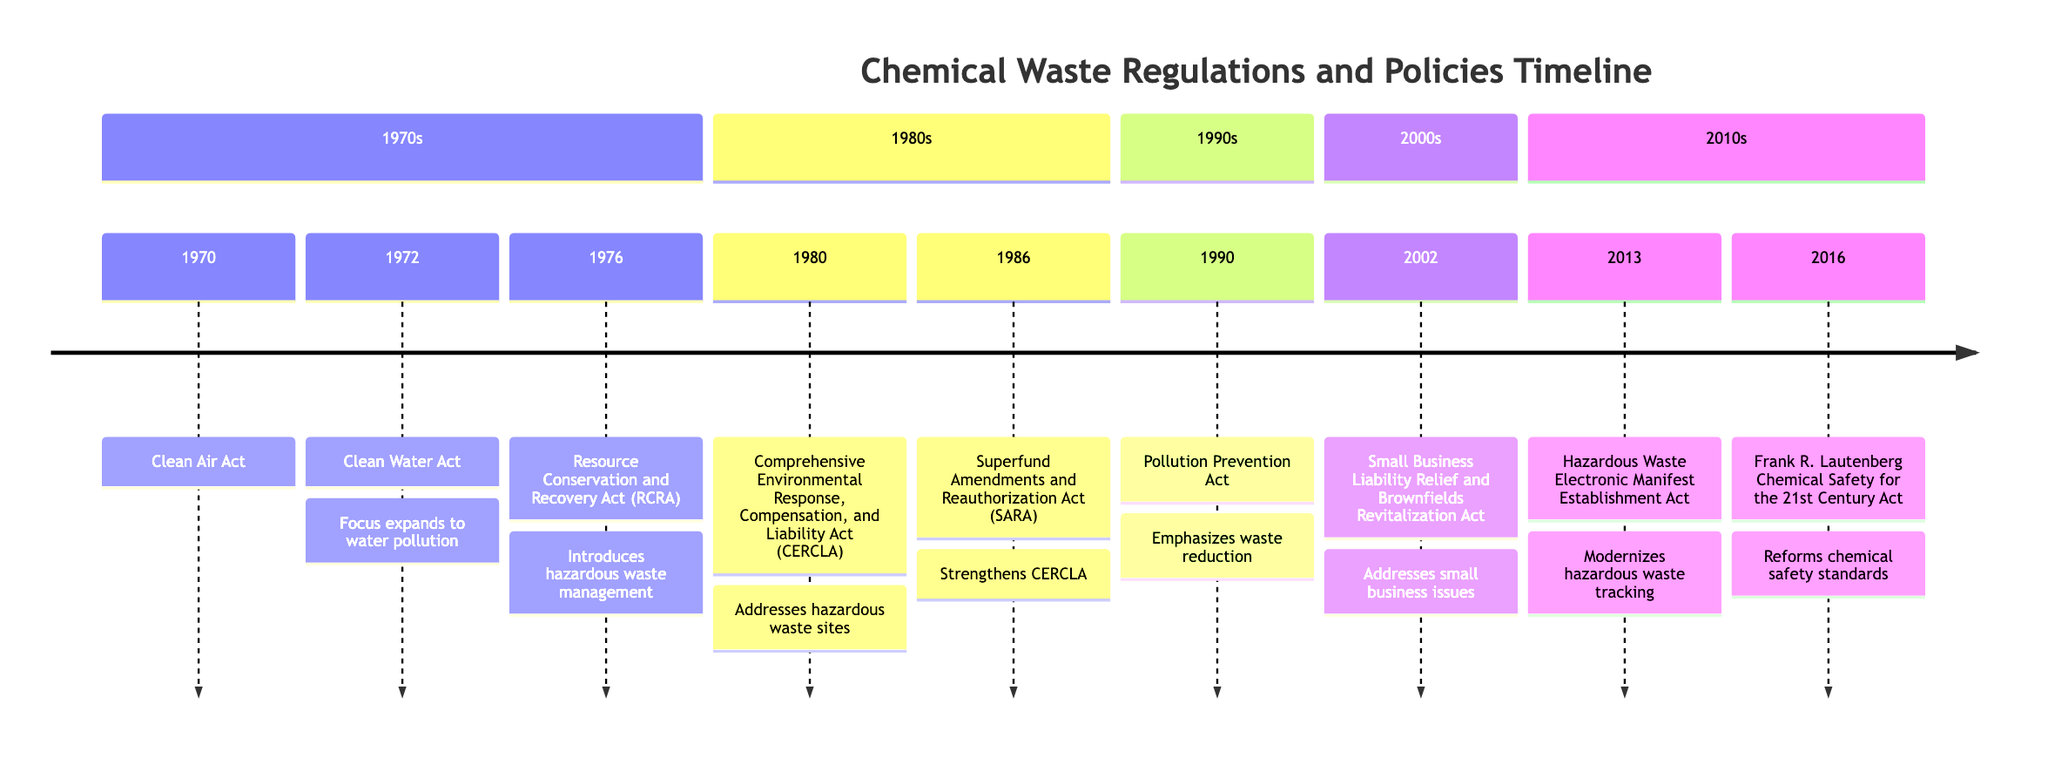What is the first regulation listed in the timeline? The timeline begins with the Clean Air Act in 1970, which is the earliest regulation presented.
Answer: Clean Air Act Which act focuses specifically on hazardous waste management? The Resource Conservation and Recovery Act (RCRA) introduced hazardous waste management in 1976.
Answer: Resource Conservation and Recovery Act How many acts were introduced in the 1980s? There are two significant acts introduced in the 1980s: CERCLA in 1980 and SARA in 1986.
Answer: 2 What change occurred in 2016 according to the timeline? The Frank R. Lautenberg Chemical Safety for the 21st Century Act was enacted in 2016, reforming chemical safety standards.
Answer: Frank R. Lautenberg Chemical Safety for the 21st Century Act Which act emphasized waste reduction and when was it enacted? The Pollution Prevention Act, enacted in 1990, focuses on waste reduction.
Answer: Pollution Prevention Act, 1990 What key milestone is linked to modernizing hazardous waste tracking? The Hazardous Waste Electronic Manifest Establishment Act in 2013 is linked to modernizing hazardous waste tracking.
Answer: Hazardous Waste Electronic Manifest Establishment Act Which two acts were related to the cleanup of hazardous waste sites? The Comprehensive Environmental Response, Compensation, and Liability Act (CERCLA) in 1980 and the Superfund Amendments and Reauthorization Act (SARA) in 1986 are both related to the cleanup of hazardous waste sites.
Answer: CERCLA and SARA In which section is the Pollution Prevention Act found? The Pollution Prevention Act is found in the 1990s section of the timeline.
Answer: 1990s What regulatory act was established to address small business issues? The Small Business Liability Relief and Brownfields Revitalization Act, enacted in 2002, addresses small business issues.
Answer: Small Business Liability Relief and Brownfields Revitalization Act 